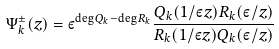Convert formula to latex. <formula><loc_0><loc_0><loc_500><loc_500>\Psi _ { k } ^ { \pm } ( z ) = \varepsilon ^ { \deg Q _ { k } - \deg R _ { k } } \frac { Q _ { k } ( 1 / \varepsilon z ) R _ { k } ( \varepsilon / z ) } { R _ { k } ( 1 / \varepsilon z ) Q _ { k } ( \varepsilon / z ) }</formula> 